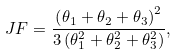<formula> <loc_0><loc_0><loc_500><loc_500>J F = \frac { \left ( \theta _ { 1 } + \theta _ { 2 } + \theta _ { 3 } \right ) ^ { 2 } } { 3 \left ( \theta _ { 1 } ^ { 2 } + \theta _ { 2 } ^ { 2 } + \theta _ { 3 } ^ { 2 } \right ) } ,</formula> 